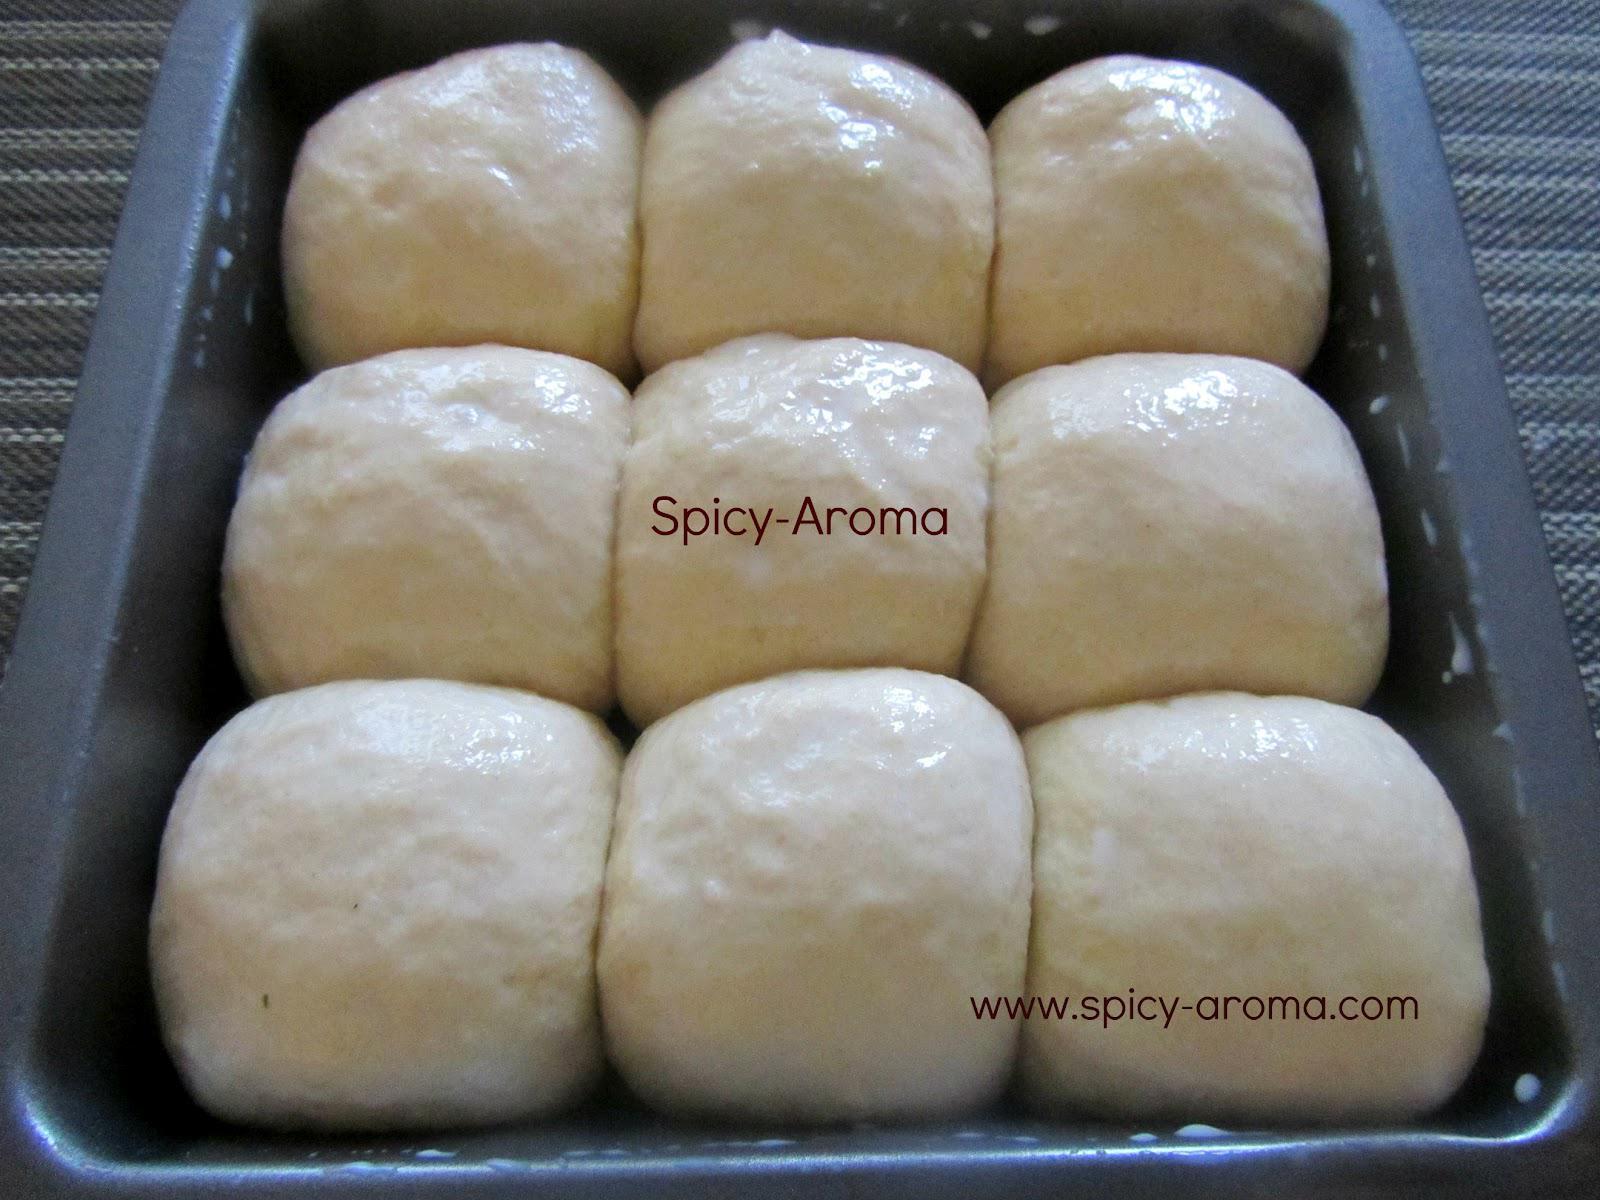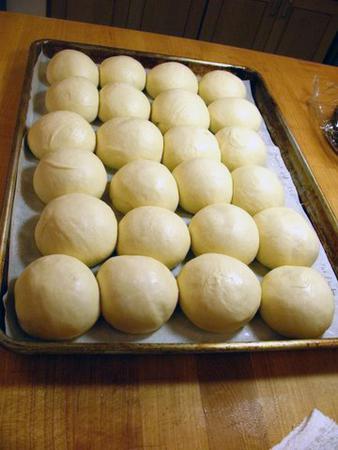The first image is the image on the left, the second image is the image on the right. Considering the images on both sides, is "One pan of dough has at least sixteen balls, and all pans have balls that are touching and not spaced out." valid? Answer yes or no. Yes. The first image is the image on the left, the second image is the image on the right. Analyze the images presented: Is the assertion "there are 6 balls of bread dough in a silver pan lined with parchment paper" valid? Answer yes or no. No. 